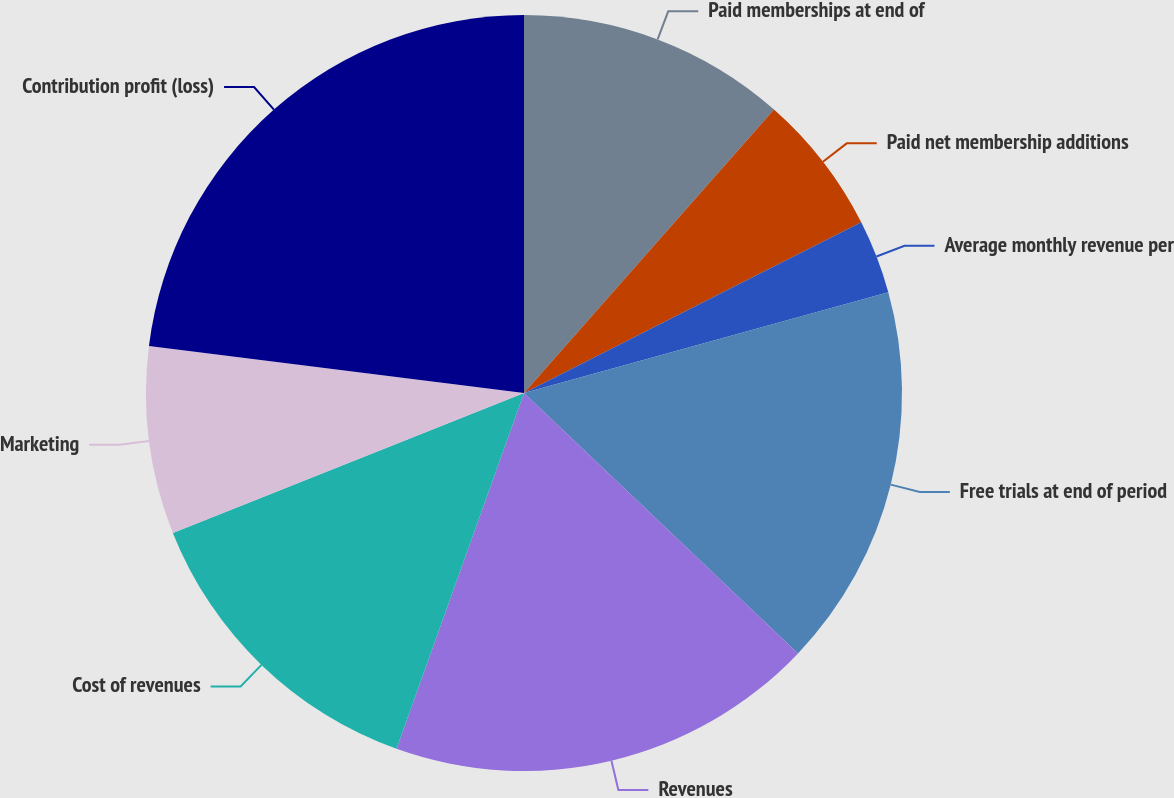Convert chart. <chart><loc_0><loc_0><loc_500><loc_500><pie_chart><fcel>Paid memberships at end of<fcel>Paid net membership additions<fcel>Average monthly revenue per<fcel>Free trials at end of period<fcel>Revenues<fcel>Cost of revenues<fcel>Marketing<fcel>Contribution profit (loss)<nl><fcel>11.5%<fcel>6.04%<fcel>3.16%<fcel>16.39%<fcel>18.38%<fcel>13.49%<fcel>8.02%<fcel>23.01%<nl></chart> 